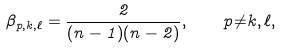Convert formula to latex. <formula><loc_0><loc_0><loc_500><loc_500>\beta _ { p , k , \ell } = \frac { 2 } { ( n - 1 ) ( n - 2 ) } , \quad p { \ne } k , \ell ,</formula> 